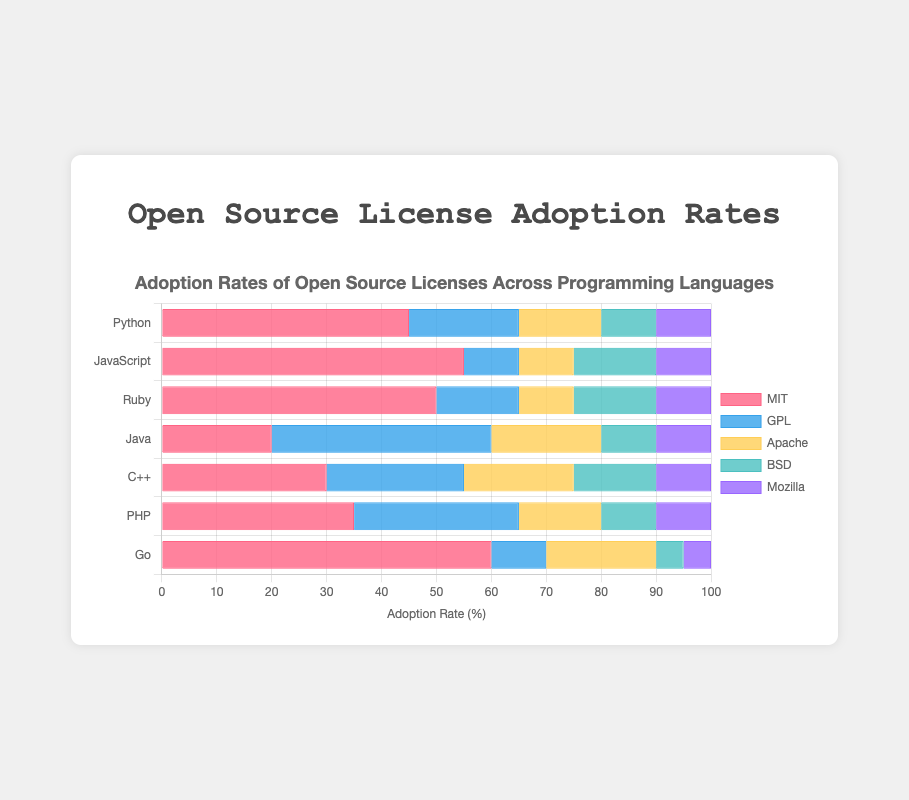Which programming language has the highest adoption rate for the MIT license? Look at the MIT license section across all programming languages. The highest adoption rate for the MIT license is 60% in Go.
Answer: Go Which programming language has the lowest adoption rate for the GPL license? Observe the GPL license section across different languages. The lowest adoption rate for the GPL license is 10% which is found in JavaScript and Go.
Answer: JavaScript and Go Which license is the least adopted among C++ projects? For C++, the adoption rates are 30% (MIT), 25% (GPL), 20% (Apache), 15% (BSD), and 10% (Mozilla). The least adopted license here is Mozilla at 10%.
Answer: Mozilla What is the difference in adoption rates between the MIT license and the Mozilla license in Python projects? In Python, the adoption rate for MIT is 45% and for Mozilla is 10%. The difference is 45% - 10% = 35%.
Answer: 35% What fraction of Java projects adopt the BSD license? The BSD license is adopted by 10% of Java projects. Since the total must be 100%, the fraction is 10/100 = 0.1 or 10%.
Answer: 0.1 Which programming language prefers the BSD license the most? By examining all BSD license sections, JavaScript and Ruby have the highest adoption rate at 15%.
Answer: JavaScript and Ruby How many languages have a higher adoption rate for the Apache license than the BSD license? Compare the adoption rates for Apache and BSD across all languages. In Python (15% vs 10%), Java (20% vs 10%), and Go (20% vs 5%), Apache rates are higher. There are 3 languages.
Answer: 3 Which license overall has the most diverse adoption rates across all languages? Calculate the range (maximum - minimum) for each license across all languages. The GPL license ranges from 10% (JavaScript, Go) to 40% (Java) which is a 30% difference, making it the most diverse.
Answer: GPL What is the average adoption rate of the MIT license across all languages? Sum up the MIT adoption rates: 45 + 55 + 50 + 20 + 30 + 35 + 60 = 295. Divide by the number of languages: 295 / 7 ≈ 42.14%.
Answer: 42.14% Which three programming languages have the highest percentage of projects under the Apache license? By checking the Apache license adoption section of all languages, the top three are Java (20%), Go (20%), and C++ (20%) each.
Answer: Java, Go, and C++ 